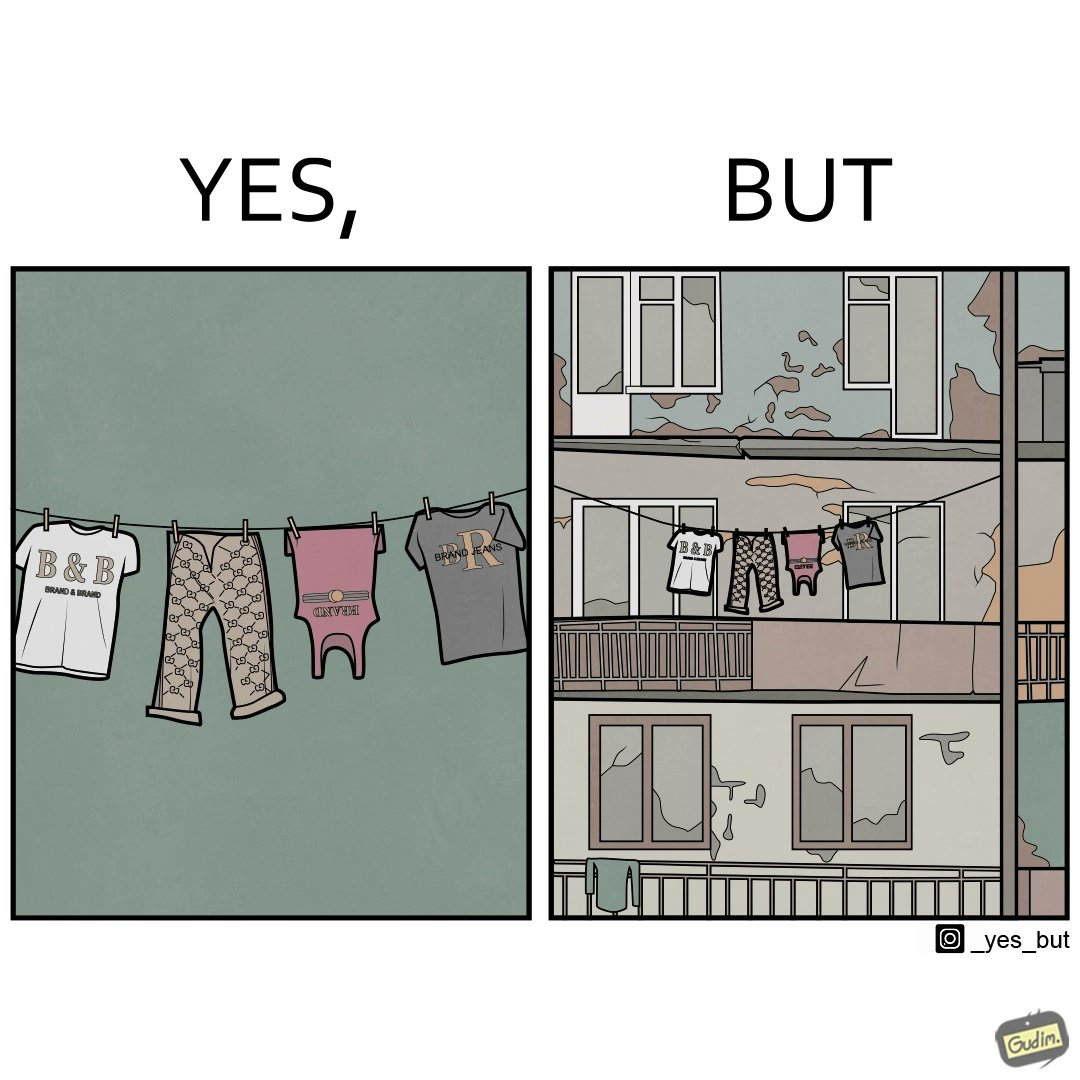Would you classify this image as satirical? Yes, this image is satirical. 